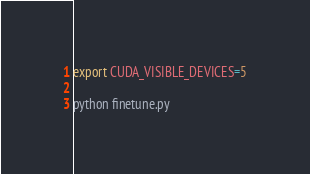Convert code to text. <code><loc_0><loc_0><loc_500><loc_500><_Bash_>export CUDA_VISIBLE_DEVICES=5

python finetune.py

</code> 